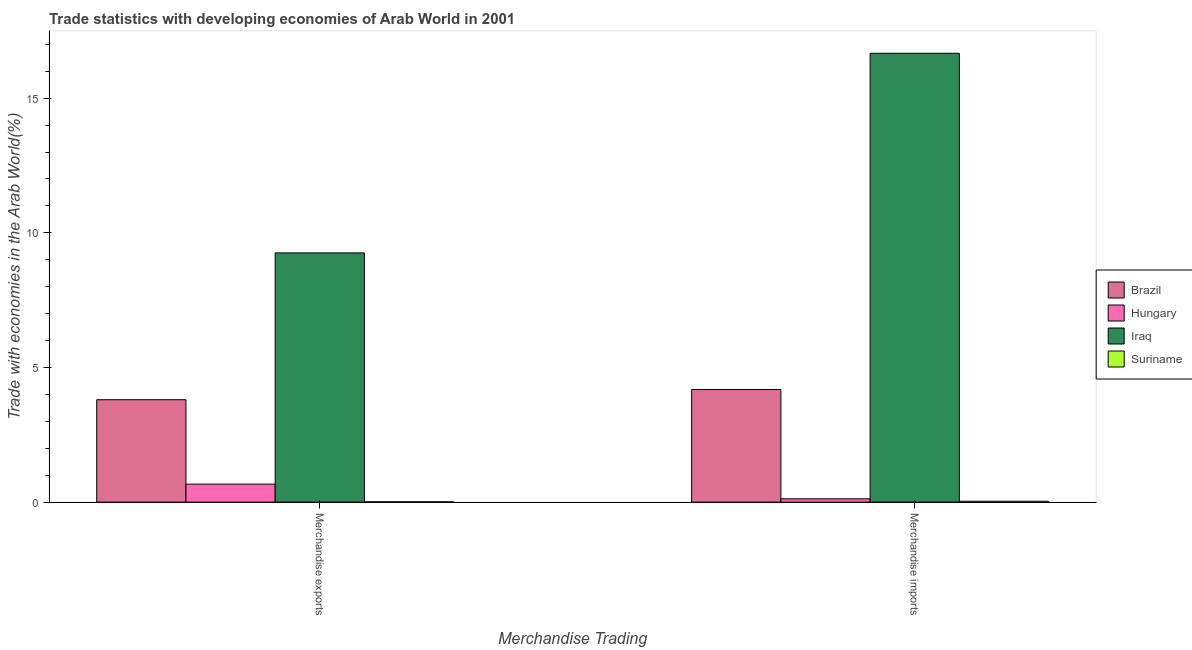How many bars are there on the 2nd tick from the left?
Make the answer very short. 4. How many bars are there on the 1st tick from the right?
Offer a terse response. 4. What is the label of the 1st group of bars from the left?
Give a very brief answer. Merchandise exports. What is the merchandise imports in Suriname?
Provide a succinct answer. 0.03. Across all countries, what is the maximum merchandise imports?
Give a very brief answer. 16.67. Across all countries, what is the minimum merchandise exports?
Offer a very short reply. 0.01. In which country was the merchandise imports maximum?
Keep it short and to the point. Iraq. In which country was the merchandise imports minimum?
Provide a short and direct response. Suriname. What is the total merchandise exports in the graph?
Make the answer very short. 13.74. What is the difference between the merchandise exports in Brazil and that in Hungary?
Offer a terse response. 3.13. What is the difference between the merchandise exports in Brazil and the merchandise imports in Iraq?
Offer a terse response. -12.87. What is the average merchandise imports per country?
Your answer should be compact. 5.25. What is the difference between the merchandise imports and merchandise exports in Brazil?
Give a very brief answer. 0.38. What is the ratio of the merchandise imports in Iraq to that in Hungary?
Make the answer very short. 135.31. What does the 4th bar from the right in Merchandise imports represents?
Your response must be concise. Brazil. Are all the bars in the graph horizontal?
Your response must be concise. No. What is the difference between two consecutive major ticks on the Y-axis?
Offer a very short reply. 5. Does the graph contain grids?
Offer a very short reply. No. Where does the legend appear in the graph?
Your answer should be very brief. Center right. How are the legend labels stacked?
Offer a very short reply. Vertical. What is the title of the graph?
Provide a short and direct response. Trade statistics with developing economies of Arab World in 2001. Does "Sub-Saharan Africa (developing only)" appear as one of the legend labels in the graph?
Ensure brevity in your answer.  No. What is the label or title of the X-axis?
Give a very brief answer. Merchandise Trading. What is the label or title of the Y-axis?
Provide a short and direct response. Trade with economies in the Arab World(%). What is the Trade with economies in the Arab World(%) of Brazil in Merchandise exports?
Your response must be concise. 3.8. What is the Trade with economies in the Arab World(%) of Hungary in Merchandise exports?
Give a very brief answer. 0.67. What is the Trade with economies in the Arab World(%) in Iraq in Merchandise exports?
Provide a short and direct response. 9.26. What is the Trade with economies in the Arab World(%) of Suriname in Merchandise exports?
Offer a very short reply. 0.01. What is the Trade with economies in the Arab World(%) of Brazil in Merchandise imports?
Your answer should be compact. 4.18. What is the Trade with economies in the Arab World(%) of Hungary in Merchandise imports?
Give a very brief answer. 0.12. What is the Trade with economies in the Arab World(%) of Iraq in Merchandise imports?
Your response must be concise. 16.67. What is the Trade with economies in the Arab World(%) of Suriname in Merchandise imports?
Ensure brevity in your answer.  0.03. Across all Merchandise Trading, what is the maximum Trade with economies in the Arab World(%) of Brazil?
Provide a short and direct response. 4.18. Across all Merchandise Trading, what is the maximum Trade with economies in the Arab World(%) of Hungary?
Keep it short and to the point. 0.67. Across all Merchandise Trading, what is the maximum Trade with economies in the Arab World(%) in Iraq?
Your response must be concise. 16.67. Across all Merchandise Trading, what is the maximum Trade with economies in the Arab World(%) of Suriname?
Offer a terse response. 0.03. Across all Merchandise Trading, what is the minimum Trade with economies in the Arab World(%) in Brazil?
Make the answer very short. 3.8. Across all Merchandise Trading, what is the minimum Trade with economies in the Arab World(%) of Hungary?
Ensure brevity in your answer.  0.12. Across all Merchandise Trading, what is the minimum Trade with economies in the Arab World(%) of Iraq?
Your answer should be very brief. 9.26. Across all Merchandise Trading, what is the minimum Trade with economies in the Arab World(%) of Suriname?
Make the answer very short. 0.01. What is the total Trade with economies in the Arab World(%) of Brazil in the graph?
Provide a succinct answer. 7.99. What is the total Trade with economies in the Arab World(%) of Hungary in the graph?
Offer a very short reply. 0.79. What is the total Trade with economies in the Arab World(%) in Iraq in the graph?
Ensure brevity in your answer.  25.92. What is the total Trade with economies in the Arab World(%) in Suriname in the graph?
Offer a terse response. 0.04. What is the difference between the Trade with economies in the Arab World(%) of Brazil in Merchandise exports and that in Merchandise imports?
Keep it short and to the point. -0.38. What is the difference between the Trade with economies in the Arab World(%) of Hungary in Merchandise exports and that in Merchandise imports?
Ensure brevity in your answer.  0.54. What is the difference between the Trade with economies in the Arab World(%) of Iraq in Merchandise exports and that in Merchandise imports?
Ensure brevity in your answer.  -7.41. What is the difference between the Trade with economies in the Arab World(%) in Suriname in Merchandise exports and that in Merchandise imports?
Your answer should be compact. -0.02. What is the difference between the Trade with economies in the Arab World(%) of Brazil in Merchandise exports and the Trade with economies in the Arab World(%) of Hungary in Merchandise imports?
Your answer should be compact. 3.68. What is the difference between the Trade with economies in the Arab World(%) of Brazil in Merchandise exports and the Trade with economies in the Arab World(%) of Iraq in Merchandise imports?
Give a very brief answer. -12.87. What is the difference between the Trade with economies in the Arab World(%) of Brazil in Merchandise exports and the Trade with economies in the Arab World(%) of Suriname in Merchandise imports?
Ensure brevity in your answer.  3.77. What is the difference between the Trade with economies in the Arab World(%) in Hungary in Merchandise exports and the Trade with economies in the Arab World(%) in Iraq in Merchandise imports?
Offer a terse response. -16. What is the difference between the Trade with economies in the Arab World(%) in Hungary in Merchandise exports and the Trade with economies in the Arab World(%) in Suriname in Merchandise imports?
Provide a succinct answer. 0.64. What is the difference between the Trade with economies in the Arab World(%) of Iraq in Merchandise exports and the Trade with economies in the Arab World(%) of Suriname in Merchandise imports?
Offer a very short reply. 9.22. What is the average Trade with economies in the Arab World(%) of Brazil per Merchandise Trading?
Your answer should be very brief. 3.99. What is the average Trade with economies in the Arab World(%) of Hungary per Merchandise Trading?
Make the answer very short. 0.4. What is the average Trade with economies in the Arab World(%) of Iraq per Merchandise Trading?
Offer a terse response. 12.96. What is the average Trade with economies in the Arab World(%) of Suriname per Merchandise Trading?
Provide a succinct answer. 0.02. What is the difference between the Trade with economies in the Arab World(%) in Brazil and Trade with economies in the Arab World(%) in Hungary in Merchandise exports?
Your answer should be compact. 3.13. What is the difference between the Trade with economies in the Arab World(%) of Brazil and Trade with economies in the Arab World(%) of Iraq in Merchandise exports?
Provide a short and direct response. -5.45. What is the difference between the Trade with economies in the Arab World(%) in Brazil and Trade with economies in the Arab World(%) in Suriname in Merchandise exports?
Give a very brief answer. 3.79. What is the difference between the Trade with economies in the Arab World(%) of Hungary and Trade with economies in the Arab World(%) of Iraq in Merchandise exports?
Make the answer very short. -8.59. What is the difference between the Trade with economies in the Arab World(%) of Hungary and Trade with economies in the Arab World(%) of Suriname in Merchandise exports?
Keep it short and to the point. 0.66. What is the difference between the Trade with economies in the Arab World(%) of Iraq and Trade with economies in the Arab World(%) of Suriname in Merchandise exports?
Your response must be concise. 9.24. What is the difference between the Trade with economies in the Arab World(%) in Brazil and Trade with economies in the Arab World(%) in Hungary in Merchandise imports?
Keep it short and to the point. 4.06. What is the difference between the Trade with economies in the Arab World(%) of Brazil and Trade with economies in the Arab World(%) of Iraq in Merchandise imports?
Provide a succinct answer. -12.49. What is the difference between the Trade with economies in the Arab World(%) in Brazil and Trade with economies in the Arab World(%) in Suriname in Merchandise imports?
Your response must be concise. 4.15. What is the difference between the Trade with economies in the Arab World(%) of Hungary and Trade with economies in the Arab World(%) of Iraq in Merchandise imports?
Ensure brevity in your answer.  -16.54. What is the difference between the Trade with economies in the Arab World(%) in Hungary and Trade with economies in the Arab World(%) in Suriname in Merchandise imports?
Provide a succinct answer. 0.09. What is the difference between the Trade with economies in the Arab World(%) in Iraq and Trade with economies in the Arab World(%) in Suriname in Merchandise imports?
Your answer should be compact. 16.64. What is the ratio of the Trade with economies in the Arab World(%) in Brazil in Merchandise exports to that in Merchandise imports?
Your response must be concise. 0.91. What is the ratio of the Trade with economies in the Arab World(%) of Hungary in Merchandise exports to that in Merchandise imports?
Make the answer very short. 5.42. What is the ratio of the Trade with economies in the Arab World(%) of Iraq in Merchandise exports to that in Merchandise imports?
Provide a succinct answer. 0.56. What is the ratio of the Trade with economies in the Arab World(%) in Suriname in Merchandise exports to that in Merchandise imports?
Your answer should be very brief. 0.34. What is the difference between the highest and the second highest Trade with economies in the Arab World(%) in Brazil?
Your response must be concise. 0.38. What is the difference between the highest and the second highest Trade with economies in the Arab World(%) in Hungary?
Your answer should be very brief. 0.54. What is the difference between the highest and the second highest Trade with economies in the Arab World(%) in Iraq?
Provide a succinct answer. 7.41. What is the difference between the highest and the second highest Trade with economies in the Arab World(%) in Suriname?
Your answer should be compact. 0.02. What is the difference between the highest and the lowest Trade with economies in the Arab World(%) in Brazil?
Your response must be concise. 0.38. What is the difference between the highest and the lowest Trade with economies in the Arab World(%) of Hungary?
Ensure brevity in your answer.  0.54. What is the difference between the highest and the lowest Trade with economies in the Arab World(%) in Iraq?
Ensure brevity in your answer.  7.41. What is the difference between the highest and the lowest Trade with economies in the Arab World(%) in Suriname?
Offer a terse response. 0.02. 